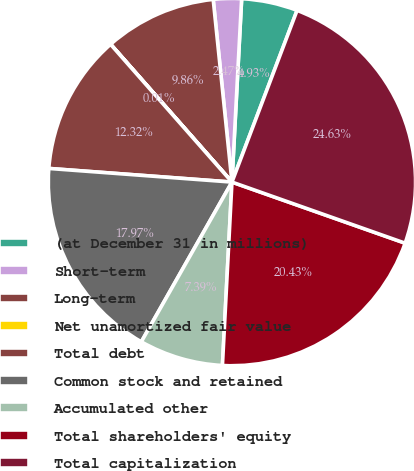<chart> <loc_0><loc_0><loc_500><loc_500><pie_chart><fcel>(at December 31 in millions)<fcel>Short-term<fcel>Long-term<fcel>Net unamortized fair value<fcel>Total debt<fcel>Common stock and retained<fcel>Accumulated other<fcel>Total shareholders' equity<fcel>Total capitalization<nl><fcel>4.93%<fcel>2.47%<fcel>9.86%<fcel>0.01%<fcel>12.32%<fcel>17.97%<fcel>7.39%<fcel>20.43%<fcel>24.63%<nl></chart> 